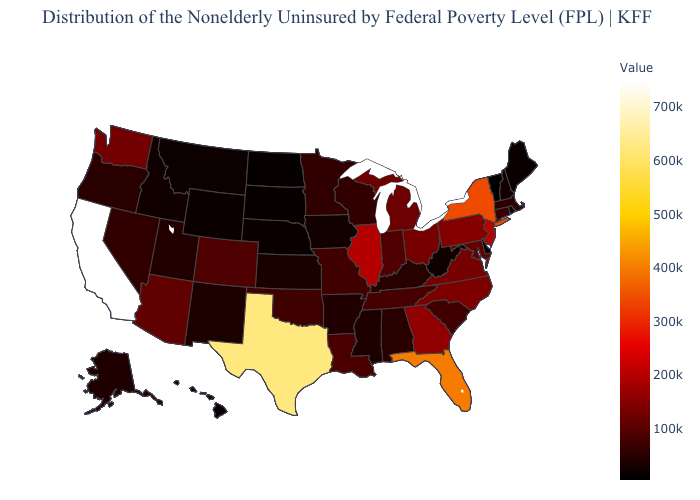Which states have the lowest value in the USA?
Concise answer only. Vermont. Does New Jersey have a lower value than Idaho?
Short answer required. No. Among the states that border Delaware , does New Jersey have the highest value?
Answer briefly. Yes. Among the states that border West Virginia , does Pennsylvania have the lowest value?
Be succinct. No. 